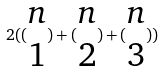<formula> <loc_0><loc_0><loc_500><loc_500>2 ( ( \begin{matrix} n \\ 1 \end{matrix} ) + ( \begin{matrix} n \\ 2 \end{matrix} ) + ( \begin{matrix} n \\ 3 \end{matrix} ) )</formula> 